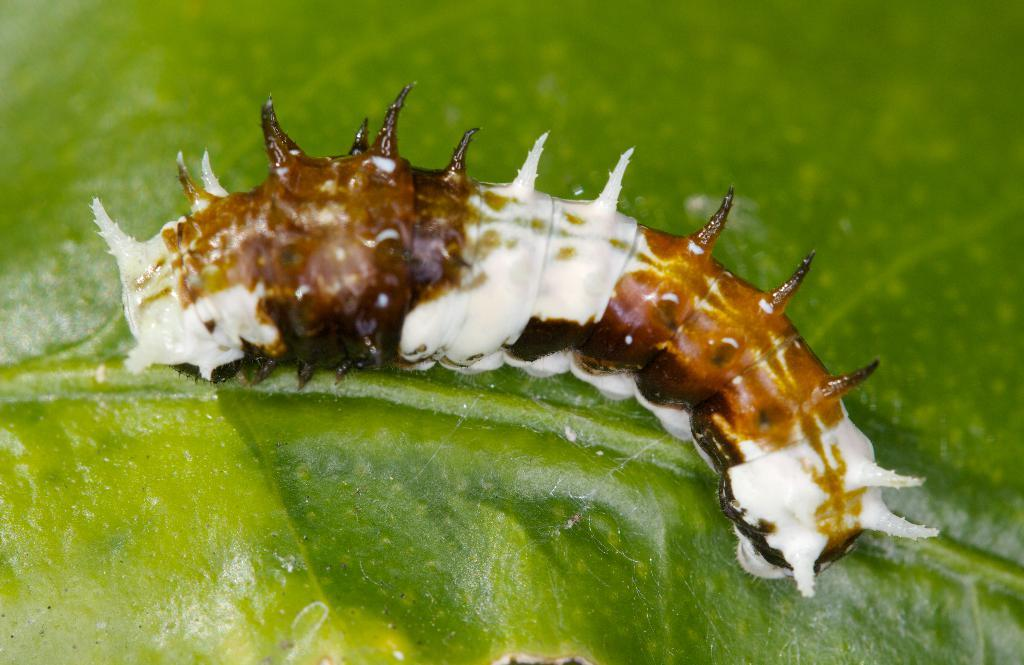What is present on the leaf in the image? There is an insect on the leaf in the image. Can you describe the location of the insect in the image? The insect is on a leaf in the image. What type of net is being used to catch the insect in the image? There is no net present in the image; the insect is on a leaf. What nerve is responsible for the insect's movement in the image? The image does not provide information about the insect's nervous system or movement. 